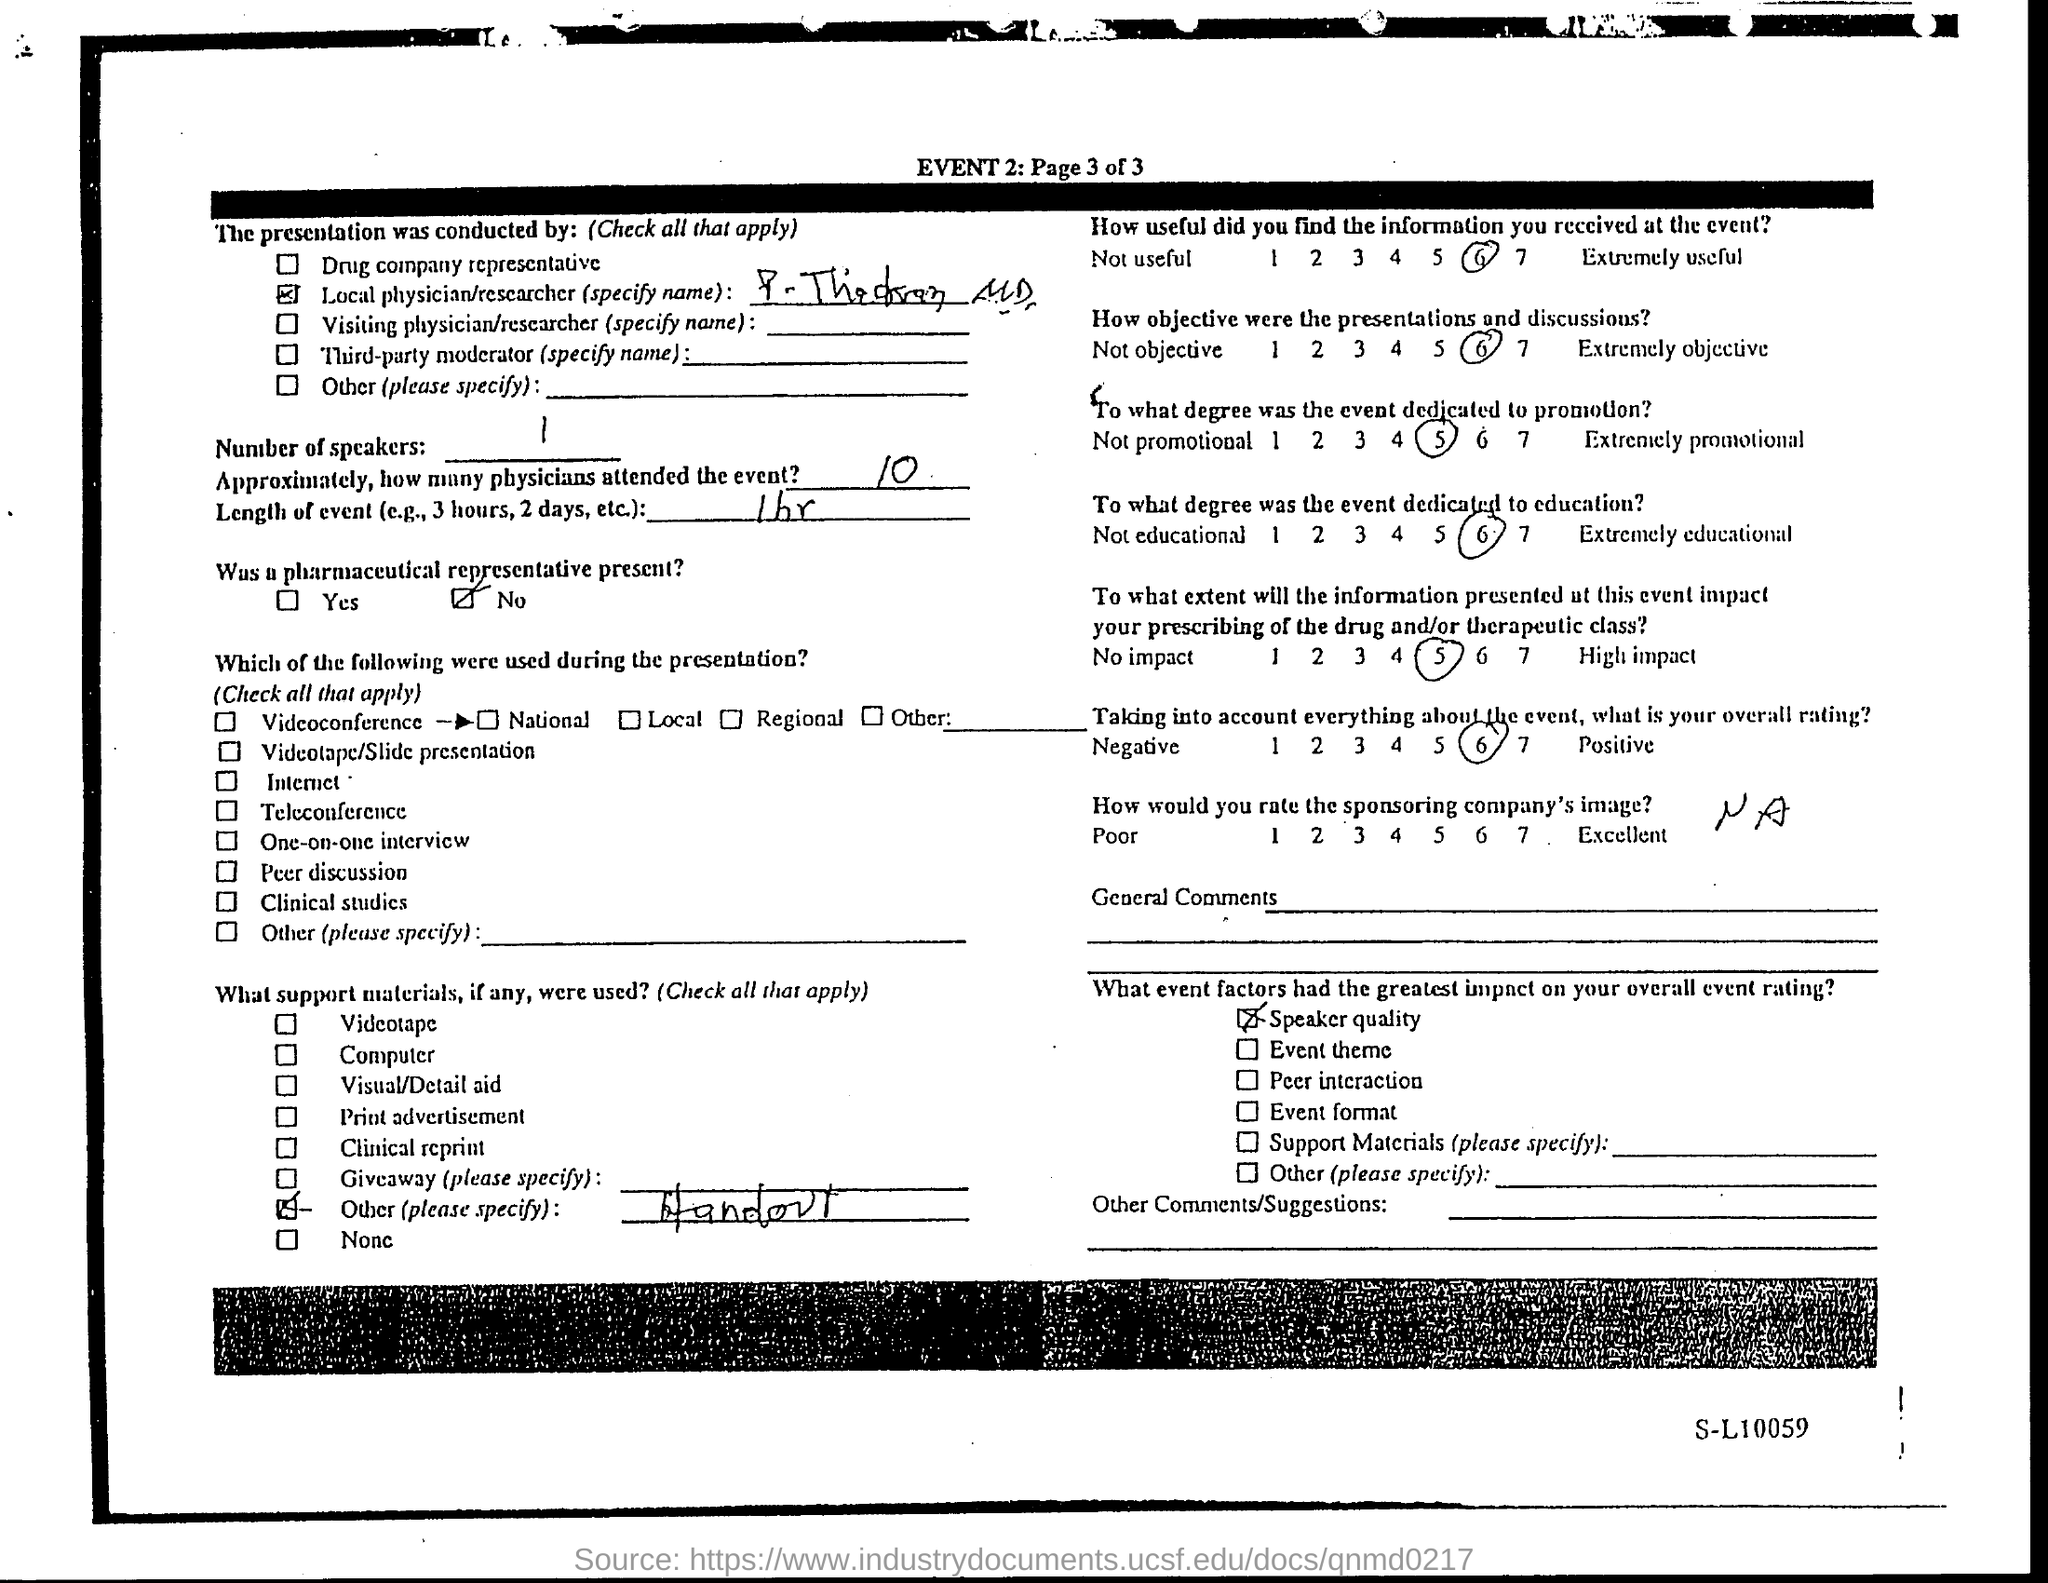What is the event number?
Offer a terse response. 2. Approximately how many physicians attended the event?
Ensure brevity in your answer.  10. What is the number of speakers?
Your response must be concise. 1. What is the length of the event?
Your response must be concise. 1 hr. Was a pharmaceutical representative present?
Provide a succinct answer. No. What is the rating given for usefulness of the information recieved at the event?
Your answer should be compact. 6. What event factors had the greatest impact on overall event rating?
Provide a short and direct response. Speaker quality. 